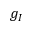Convert formula to latex. <formula><loc_0><loc_0><loc_500><loc_500>g _ { I }</formula> 